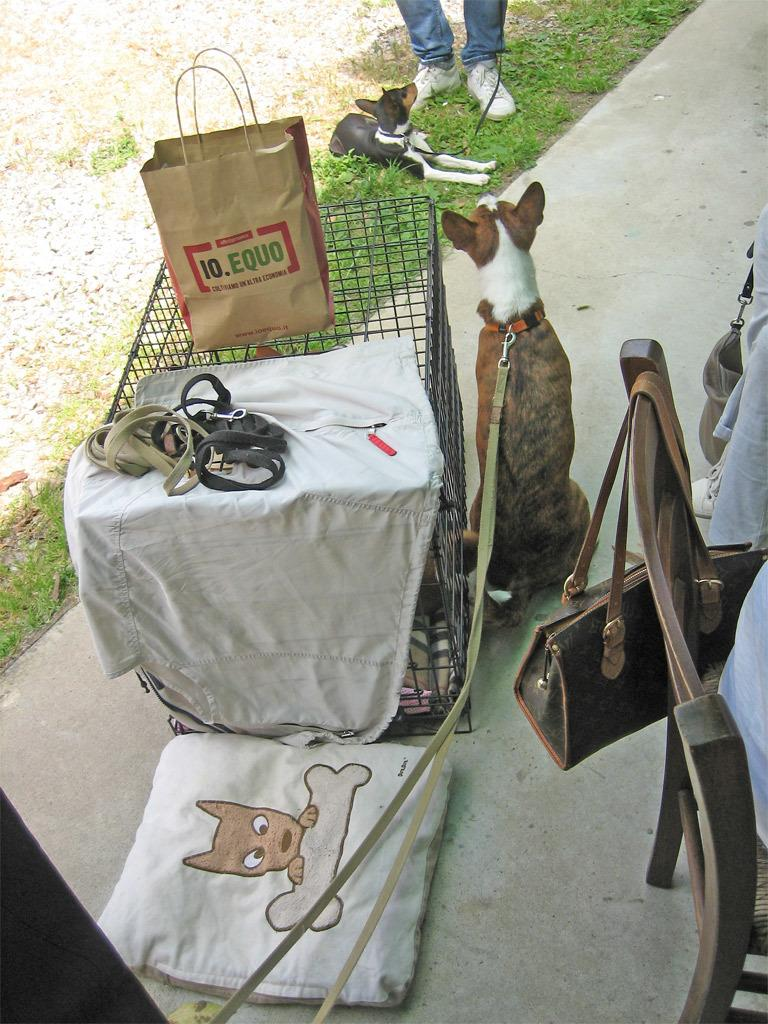What type of animals can be seen in the image? There are dogs in the image. What items are related to the dogs in the image? There are dog belts in the image. What type of furniture is present in the image? There is a chair in the image. What type of textile is visible in the image? There is cloth in the image. What type of enclosure is present in the image? There is a cage in the image. What type of accessory is present in the image? There is a handbag in the image. What type of natural environment is visible in the image? There is grass in the image. What type of plant debris is visible in the image? There are dry leaves in the image. Are there any people present in the image? Yes, there are people in the image. What is the caption of the image? There is no caption present in the image. What type of organization is depicted in the image? There is no organization depicted in the image. 